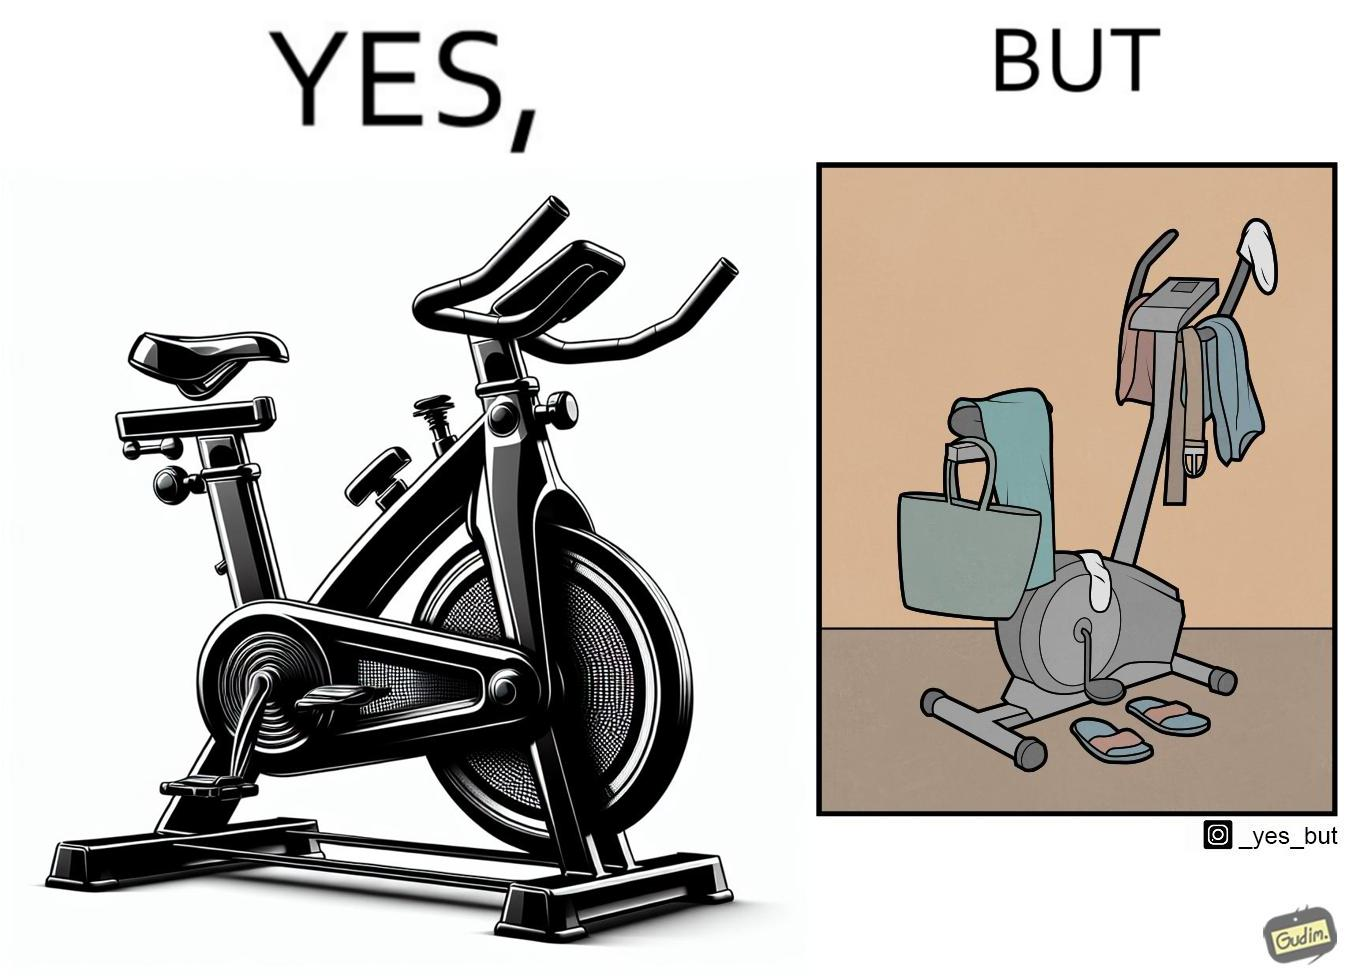Compare the left and right sides of this image. In the left part of the image: An exercise bike In the right part of the image: An exercise bike being used to hang clothes and other items 